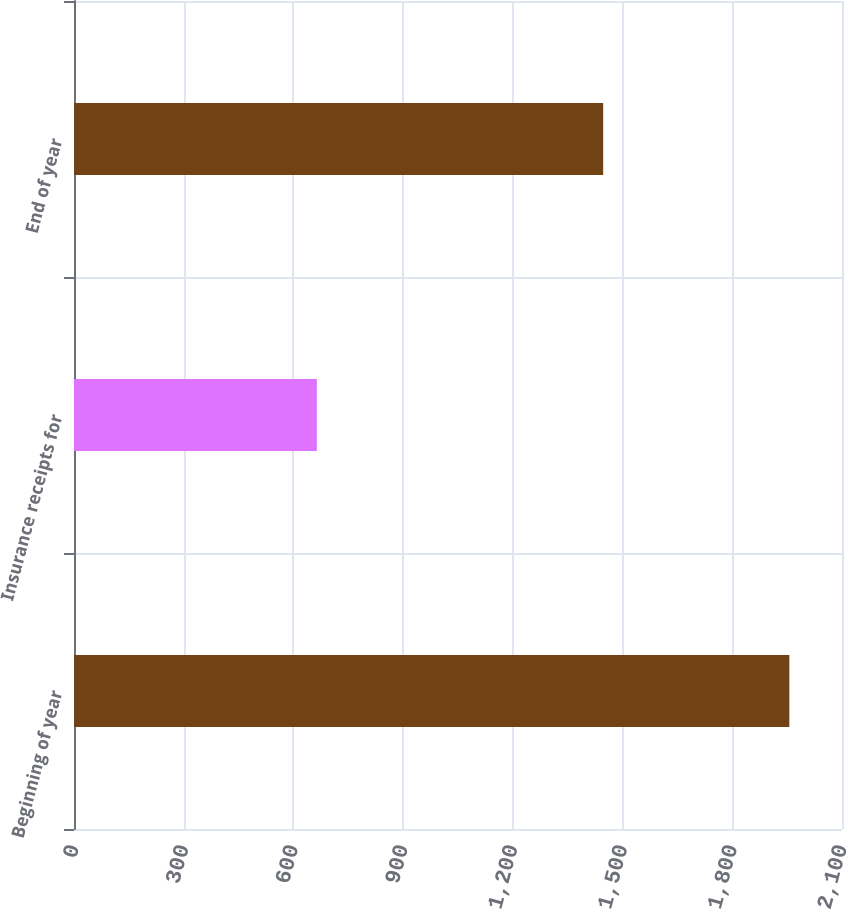Convert chart. <chart><loc_0><loc_0><loc_500><loc_500><bar_chart><fcel>Beginning of year<fcel>Insurance receipts for<fcel>End of year<nl><fcel>1956<fcel>664<fcel>1447<nl></chart> 